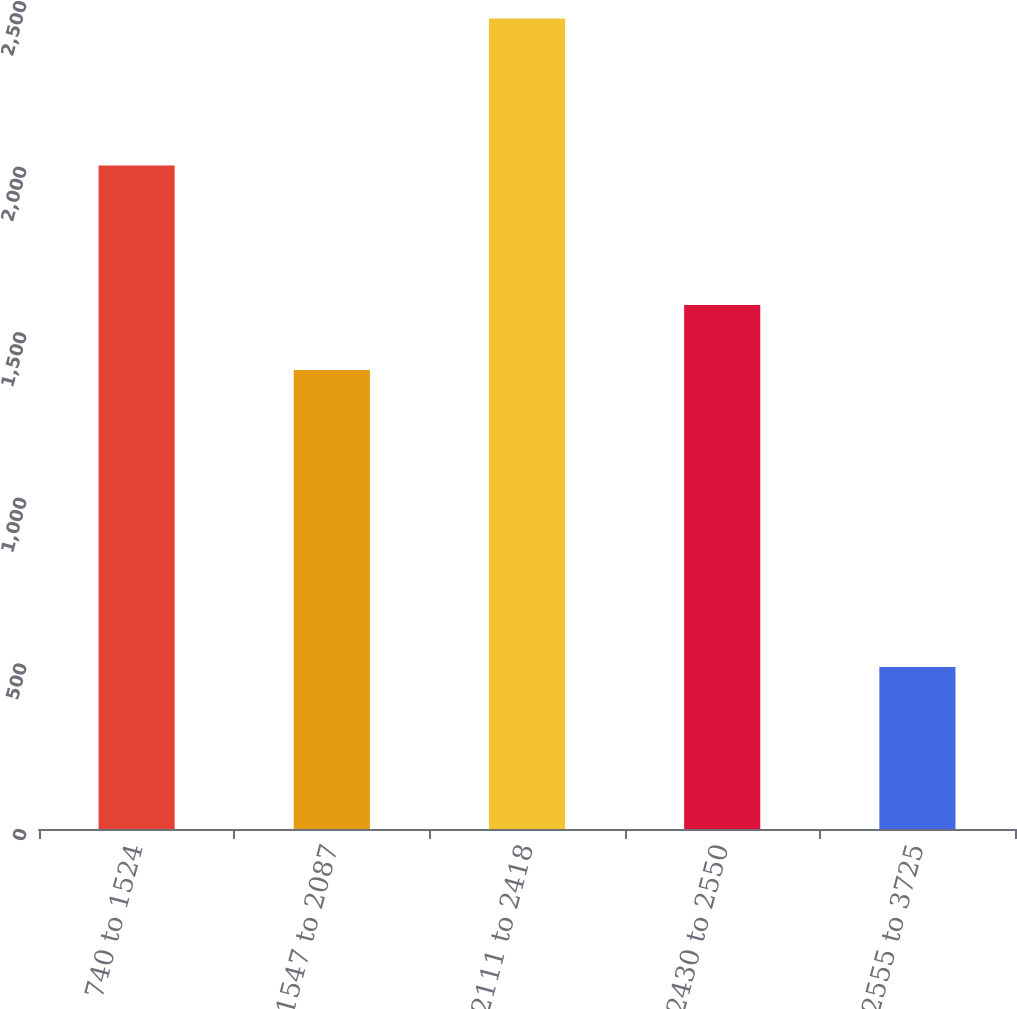<chart> <loc_0><loc_0><loc_500><loc_500><bar_chart><fcel>740 to 1524<fcel>1547 to 2087<fcel>2111 to 2418<fcel>2430 to 2550<fcel>2555 to 3725<nl><fcel>2003<fcel>1386<fcel>2447<fcel>1581.8<fcel>489<nl></chart> 